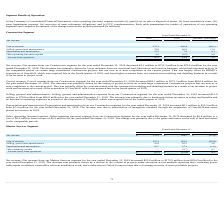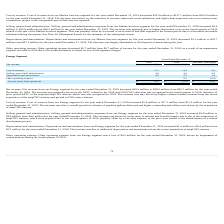According to Hc2 Holdings's financial document, What was the net revenue for the year ended December 31, 2019? According to the financial document, $39.0 million. The relevant text states: "ended December 31, 2019 increased $18.3 million to $39.0 million from $20.7 million for the year ended December 31, 2018. The increase was primarily driven by the AF..." Also, What was the net revenue for the year ended December 31, 2018? According to the financial document, $20.7 million. The relevant text states: "2019 increased $18.3 million to $39.0 million from $20.7 million for the year ended December 31, 2018. The increase was primarily driven by the AFTC related to the 2..." Also, What was the cost of revenue for the year ended December 31, 2019? According to the financial document, $17.1 million. The relevant text states: "ended December 31, 2019 increased $5.9 million to $17.1 million from $11.2 million for the year ended December 31, 2018. The increase was due to overall growth in v..." Also, can you calculate: What was the percentage change in the net revenue from 2018 to 2019? To answer this question, I need to perform calculations using the financial data. The calculation is: 39.0 / 20.7 - 1, which equals 88.41 (percentage). This is based on the information: "Net revenue $ 39.0 $ 20.7 $ 18.3 Net revenue $ 39.0 $ 20.7 $ 18.3..." The key data points involved are: 20.7, 39.0. Also, can you calculate: What was the average cost of revenue for 2018 and 2019? To answer this question, I need to perform calculations using the financial data. The calculation is: (17.1 + 11.2) / 2, which equals 14.15 (in millions). This is based on the information: "Cost of revenue 17.1 11.2 5.9 Cost of revenue 17.1 11.2 5.9..." The key data points involved are: 11.2, 17.1. Also, can you calculate: What is the percentage change in the Depreciation and amortization from 2018 to 2019? To answer this question, I need to perform calculations using the financial data. The calculation is: 6.9 / 5.5 - 1, which equals 25.45 (percentage). This is based on the information: "Depreciation and amortization 6.9 5.5 1.4 Depreciation and amortization 6.9 5.5 1.4..." The key data points involved are: 5.5, 6.9. 